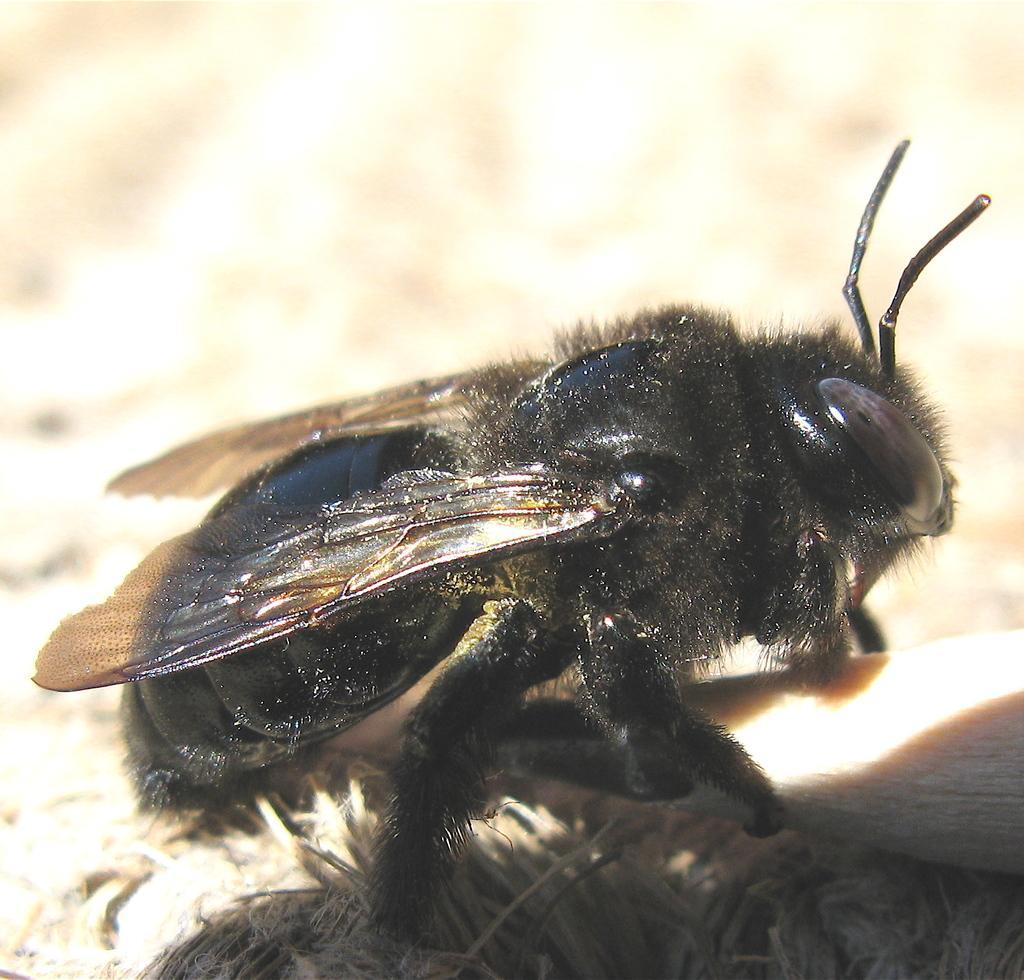How would you summarize this image in a sentence or two? There is a black color insect with wings. In the background it is blurred. 